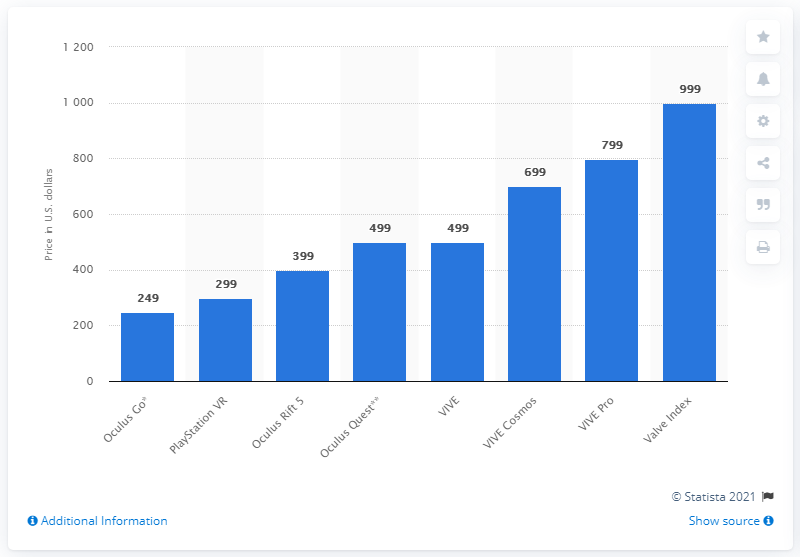List a handful of essential elements in this visual. The Valve Index VR headset reportedly had the highest cost among the leading VR headsets. 